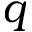<formula> <loc_0><loc_0><loc_500><loc_500>q</formula> 